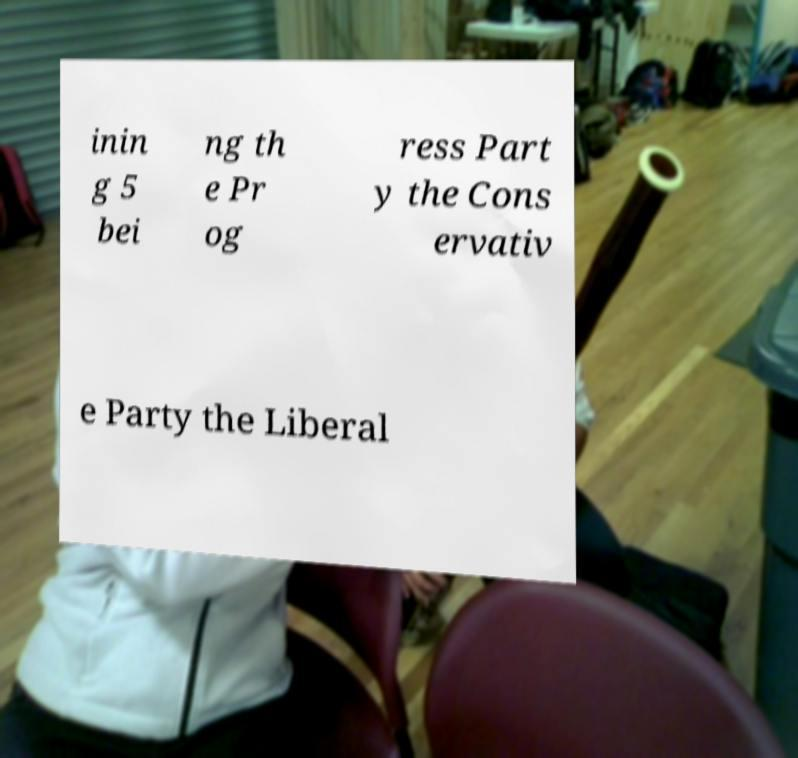For documentation purposes, I need the text within this image transcribed. Could you provide that? inin g 5 bei ng th e Pr og ress Part y the Cons ervativ e Party the Liberal 